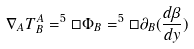<formula> <loc_0><loc_0><loc_500><loc_500>\nabla _ { A } T _ { B } ^ { A } = ^ { 5 } \Box \Phi _ { B } = ^ { 5 } \Box \partial _ { B } ( \frac { d \beta } { d y } )</formula> 